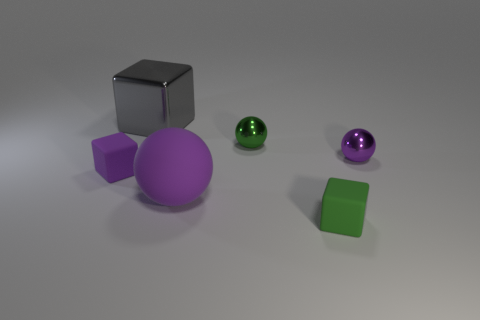What is the color of the metal ball that is the same size as the purple metallic thing? The metal ball that matches the size of the purple object, which appears to be a large spherical shape, is green in color. It has a glossy finish that reflects the light, similar to the sheen on the purple object. 